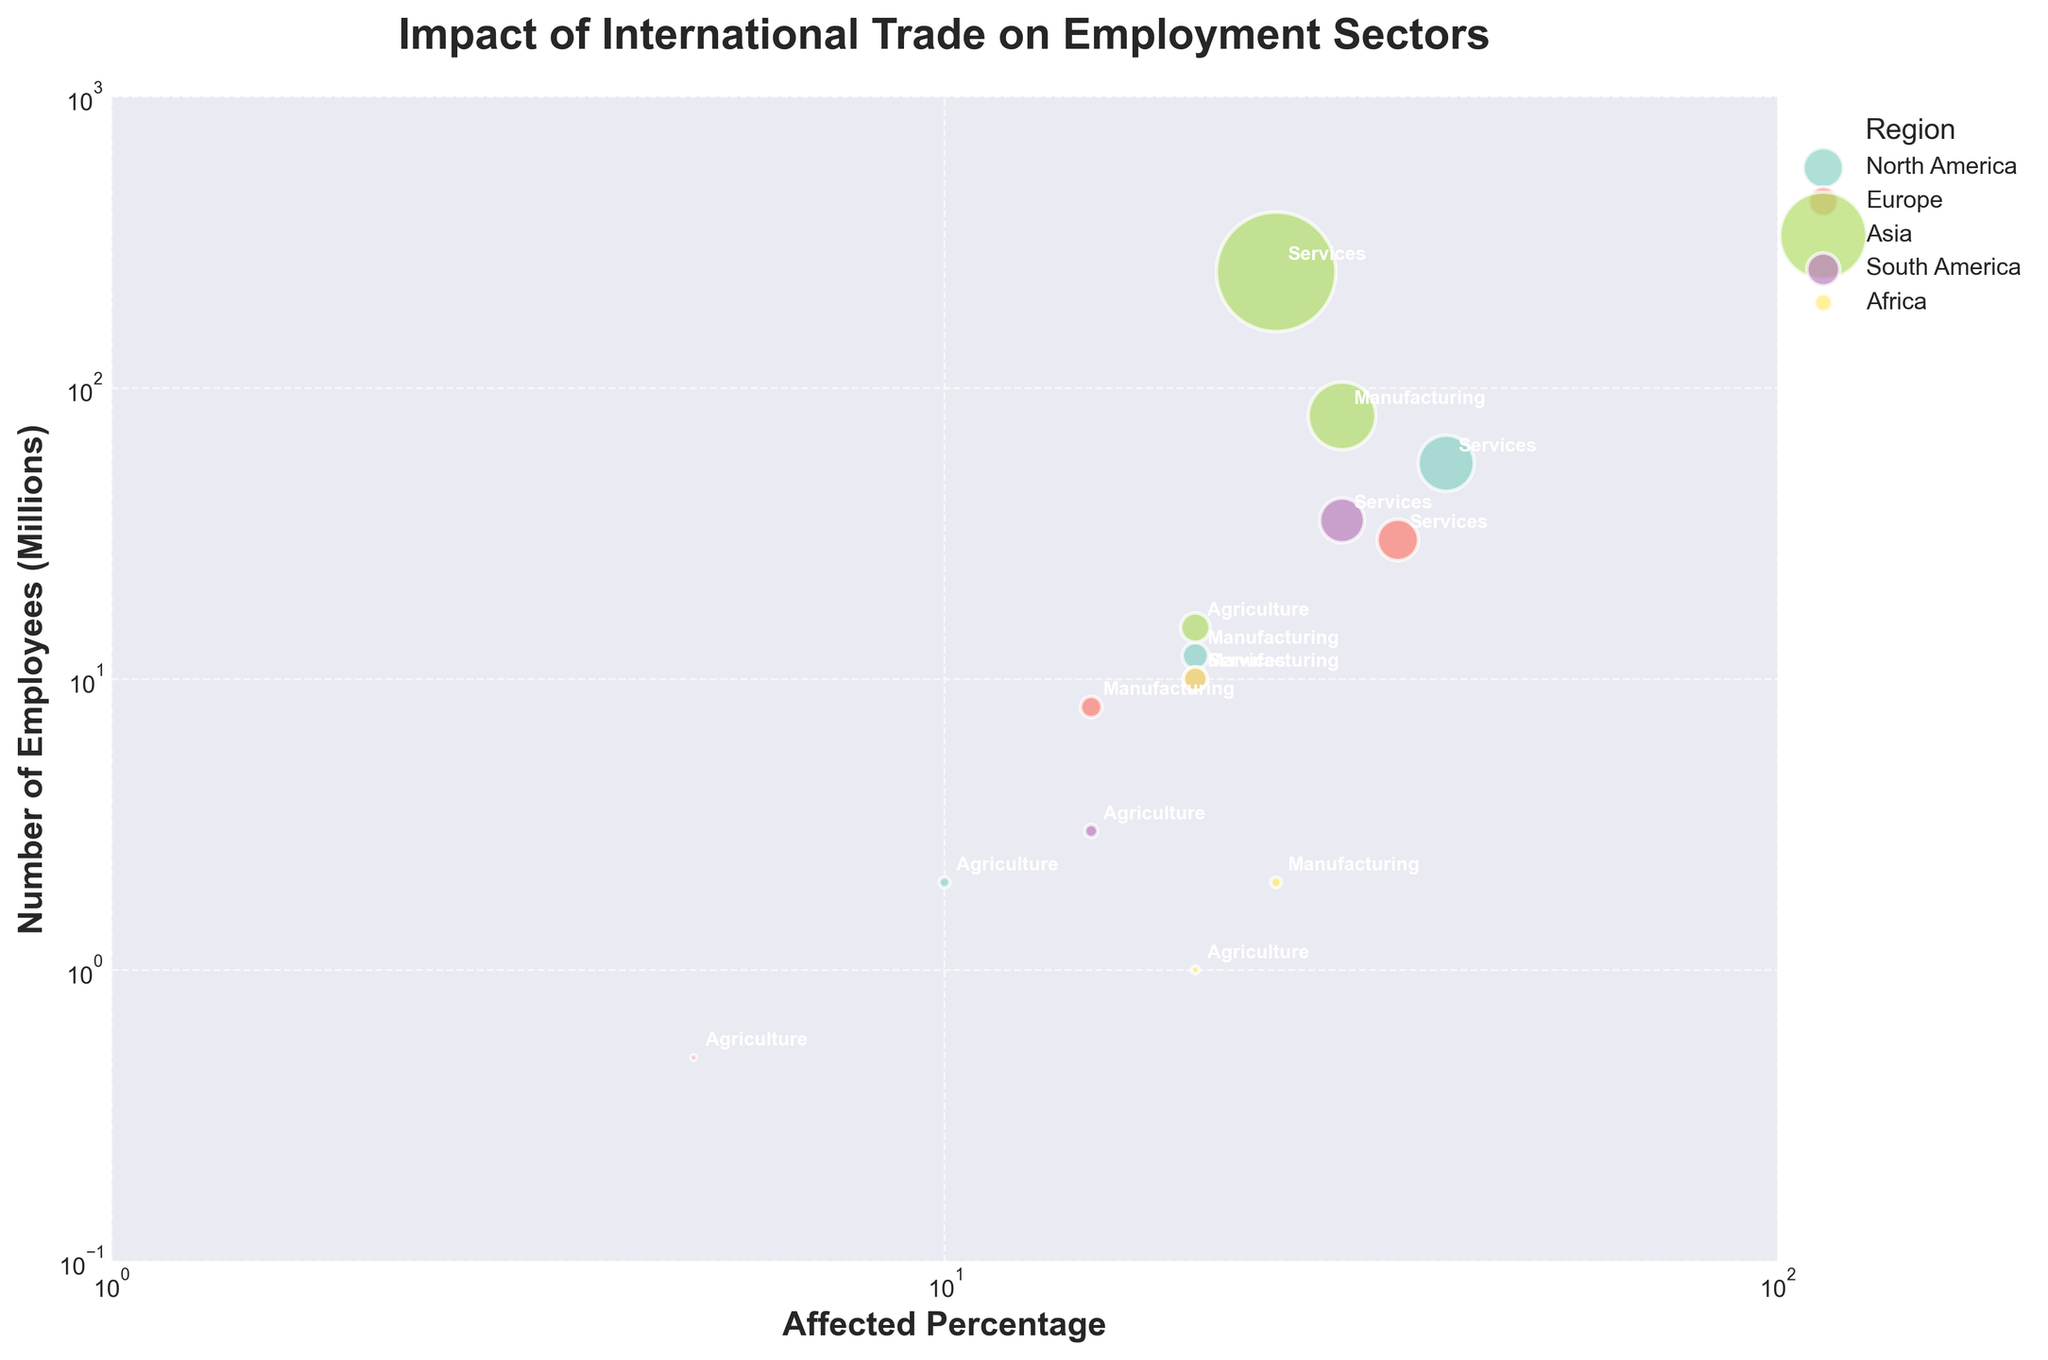What's the title of the figure? The title of the figure is displayed prominently at the top and reads "Impact of International Trade on Employment Sectors".
Answer: Impact of International Trade on Employment Sectors Which region has the largest bubble for the service sector? The bubble size indicates the number of employees affected. The largest bubble for the service sector is visibly the one in the Asia region, specifically China.
Answer: Asia What is the x-axis representing? The x-axis of the figure is labeled "Affected Percentage", showing the percentage of employees affected by international trade.
Answer: Affected Percentage How many sectors are represented for each country? Each country has three employment sectors represented as indicated by the annotations: agriculture, manufacturing, and services.
Answer: Three Which sector in South America has the highest affected percentage? To find the highest affected percentage for South America, look at the bubbles in that region and compare their x-axis positions. For South America, Brazil's manufacturing sector has the highest affected percentage at 20%.
Answer: Manufacturing Among the countries listed, which has the highest number of employees in the manufacturing sector? To find this, compare the y-axis values for the manufacturing sector bubbles in all countries. China's manufacturing sector has the highest number of employees, indicated by the highest position on the y-axis.
Answer: China In Europe, compare the affected percentage of the agriculture sector with the manufacturing sector. In the Europe region, the agriculture sector has an affected percentage of 5%, while the manufacturing sector has an affected percentage of 15%. The manufacturing sector has a higher affected percentage.
Answer: Manufacturing sector has a higher percentage For the services sector, which country in North America has a higher number of affected employees compared to Europe? Compare the y-axis values for the services sector for North America (United States) and Europe (Germany). The United States has 55 million affected employees, while Germany has 30 million. So, the United States has a higher number.
Answer: United States What is the number of employees for the agriculture sector in Africa? Locate the agriculture bubble for South Africa in the Africa region and read the y-axis value. The agriculture sector has 1 million employees.
Answer: 1 million Which region has the least affected agricultural sector by percentage? Examine the x-axis values for the agriculture sector in all regions. Europe (Germany) has the least affected percentage for agriculture at 5%.
Answer: Europe 